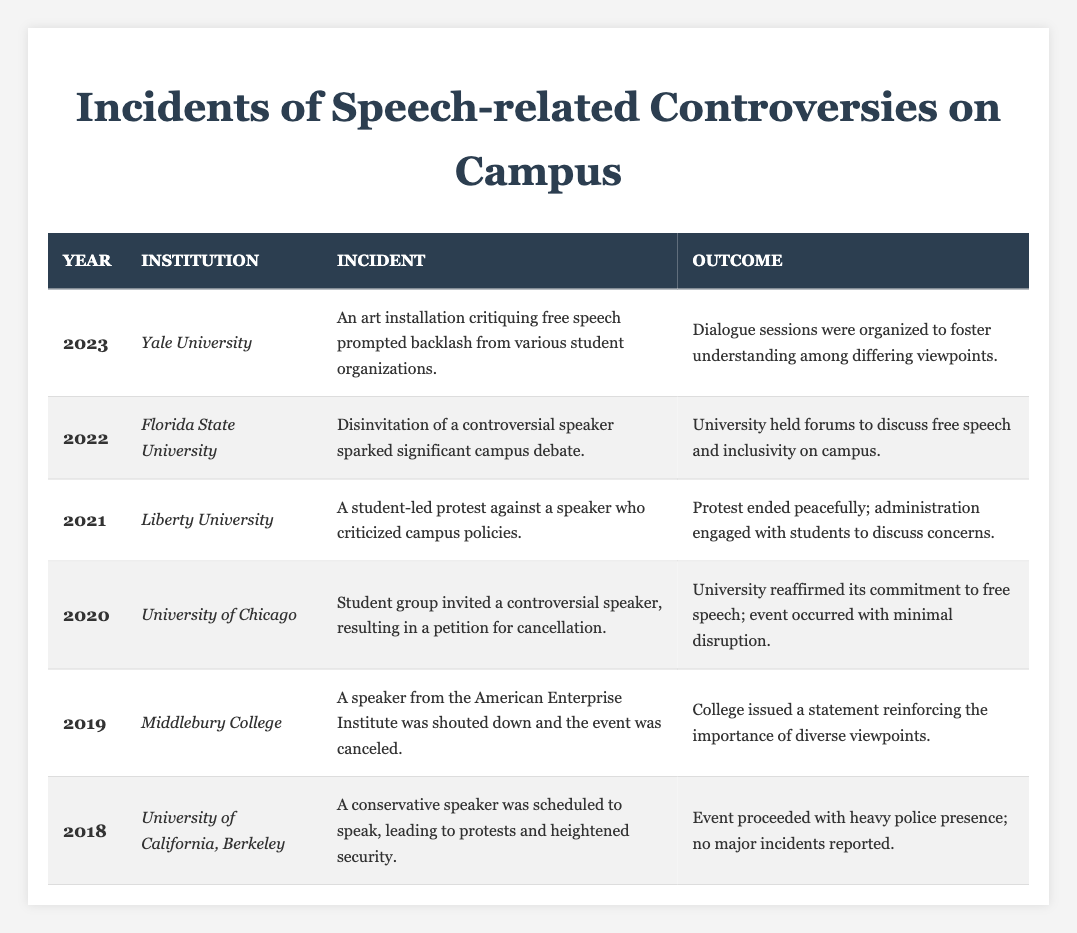What incident occurred at Liberty University in 2021? The table lists the incident that occurred at Liberty University in 2021 as a student-led protest against a speaker who criticized campus policies.
Answer: A student-led protest against a speaker who criticized campus policies How many years are represented in the table? The table includes incidents from six different years: 2018, 2019, 2020, 2021, 2022, and 2023. Therefore, the total is 6.
Answer: 6 Did the University of Chicago experience any major disruptions in 2020 regarding the invited speaker? The table indicates that the University of Chicago reaffirmed its commitment to free speech, and the event occurred with minimal disruption, suggesting that there were no major disruptions.
Answer: No Which institution had a controversy related to disinviting a speaker, and in what year did it occur? Referring to the table, Florida State University faced a controversy regarding the disinvitation of a controversial speaker in 2022.
Answer: Florida State University in 2022 What was the outcome of the incident at Middlebury College in 2019? According to the table, the outcome of the incident at Middlebury College in 2019 was that the college issued a statement reinforcing the importance of diverse viewpoints after a speaker was canceled.
Answer: College issued a statement reinforcing the importance of diverse viewpoints In which year did the most recent incident occur, and what was it about? The most recent incident occurred in 2023 at Yale University. It involved an art installation critiquing free speech that prompted backlash from various student organizations.
Answer: 2023, an art installation critiquing free speech What is the average outcome for incidents described in the table across all listed years? Examining the outcomes listed, each response indicates a varied approach from campuses, with some reinforcing free speech, others leading to forums or dialogue, and generally all ending without major incidents. Summarizing qualitatively suggests that outcomes generally favored dialogue and discussion, but quantifying it leads to complexity. Consequently, the average is not a straightforward numerical value, but a reflection of diverging responses, primarily of events proceeding without major disruption or violence.
Answer: Outcomes generally favored dialogue and discussion How does the outcome of the incident at the University of California, Berkeley in 2018 compare to that of Florida State University in 2022? The outcome of the University of California, Berkeley in 2018 had the event proceeding with heavy police presence and no major incidents reported; in contrast, Florida State University in 2022 initiated forums to discuss the topic of free speech and inclusivity, indicating a proactive approach to dialoguing about the issue rather than just responding to it passively.
Answer: Different approaches: one was reactive with police presence; the other was proactive with forums 